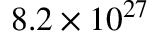<formula> <loc_0><loc_0><loc_500><loc_500>8 . 2 \times 1 0 ^ { 2 7 }</formula> 